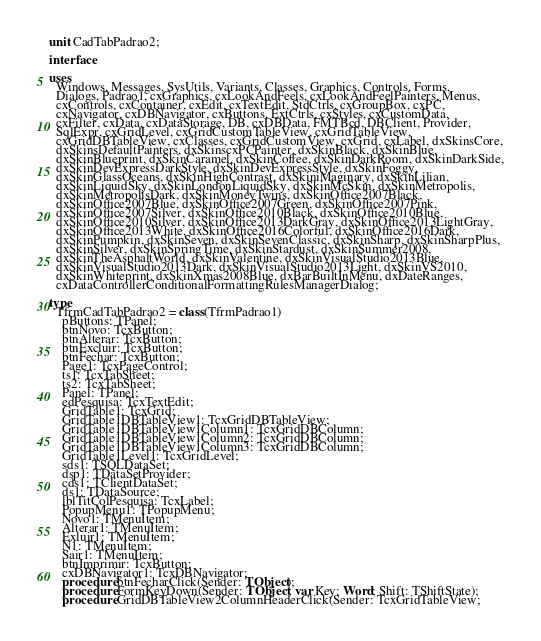Convert code to text. <code><loc_0><loc_0><loc_500><loc_500><_Pascal_>unit CadTabPadrao2;

interface

uses
  Windows, Messages, SysUtils, Variants, Classes, Graphics, Controls, Forms,
  Dialogs, Padrao1, cxGraphics, cxLookAndFeels, cxLookAndFeelPainters, Menus,
  cxControls, cxContainer, cxEdit, cxTextEdit, StdCtrls, cxGroupBox, cxPC,
  cxNavigator, cxDBNavigator, cxButtons, ExtCtrls, cxStyles, cxCustomData,
  cxFilter, cxData, cxDataStorage, DB, cxDBData, FMTBcd, DBClient, Provider,
  SqlExpr, cxGridLevel, cxGridCustomTableView, cxGridTableView,
  cxGridDBTableView, cxClasses, cxGridCustomView, cxGrid, cxLabel, dxSkinsCore,
  dxSkinsDefaultPainters, dxSkinscxPCPainter, dxSkinBlack, dxSkinBlue,
  dxSkinBlueprint, dxSkinCaramel, dxSkinCoffee, dxSkinDarkRoom, dxSkinDarkSide,
  dxSkinDevExpressDarkStyle, dxSkinDevExpressStyle, dxSkinFoggy,
  dxSkinGlassOceans, dxSkinHighContrast, dxSkiniMaginary, dxSkinLilian,
  dxSkinLiquidSky, dxSkinLondonLiquidSky, dxSkinMcSkin, dxSkinMetropolis,
  dxSkinMetropolisDark, dxSkinMoneyTwins, dxSkinOffice2007Black,
  dxSkinOffice2007Blue, dxSkinOffice2007Green, dxSkinOffice2007Pink,
  dxSkinOffice2007Silver, dxSkinOffice2010Black, dxSkinOffice2010Blue,
  dxSkinOffice2010Silver, dxSkinOffice2013DarkGray, dxSkinOffice2013LightGray,
  dxSkinOffice2013White, dxSkinOffice2016Colorful, dxSkinOffice2016Dark,
  dxSkinPumpkin, dxSkinSeven, dxSkinSevenClassic, dxSkinSharp, dxSkinSharpPlus,
  dxSkinSilver, dxSkinSpringTime, dxSkinStardust, dxSkinSummer2008,
  dxSkinTheAsphaltWorld, dxSkinValentine, dxSkinVisualStudio2013Blue,
  dxSkinVisualStudio2013Dark, dxSkinVisualStudio2013Light, dxSkinVS2010,
  dxSkinWhiteprint, dxSkinXmas2008Blue, dxBarBuiltInMenu, dxDateRanges,
  cxDataControllerConditionalFormattingRulesManagerDialog;

type
  TfrmCadTabPadrao2 = class(TfrmPadrao1)
    pButtons: TPanel;
    btnNovo: TcxButton;
    btnAlterar: TcxButton;
    btnExcluir: TcxButton;
    btnFechar: TcxButton;
    Page1: TcxPageControl;
    ts1: TcxTabSheet;
    ts2: TcxTabSheet;
    Panel: TPanel;
    edPesquisa: TcxTextEdit;
    GridTable1: TcxGrid;
    GridTable1DBTableView1: TcxGridDBTableView;
    GridTable1DBTableView1Column1: TcxGridDBColumn;
    GridTable1DBTableView1Column2: TcxGridDBColumn;
    GridTable1DBTableView1Column3: TcxGridDBColumn;
    GridTable1Level1: TcxGridLevel;
    sds1: TSQLDataSet;
    dsp1: TDataSetProvider;
    cds1: TClientDataSet;
    ds1: TDataSource;
    lblTitColPesquisa: TcxLabel;
    PopupMenu1: TPopupMenu;
    Novo1: TMenuItem;
    Alterar1: TMenuItem;
    Exluir1: TMenuItem;
    N1: TMenuItem;
    Sair1: TMenuItem;
    btnImprimir: TcxButton;
    cxDBNavigator1: TcxDBNavigator;
    procedure btnFecharClick(Sender: TObject);
    procedure FormKeyDown(Sender: TObject; var Key: Word; Shift: TShiftState);
    procedure GridDBTableView2ColumnHeaderClick(Sender: TcxGridTableView;</code> 